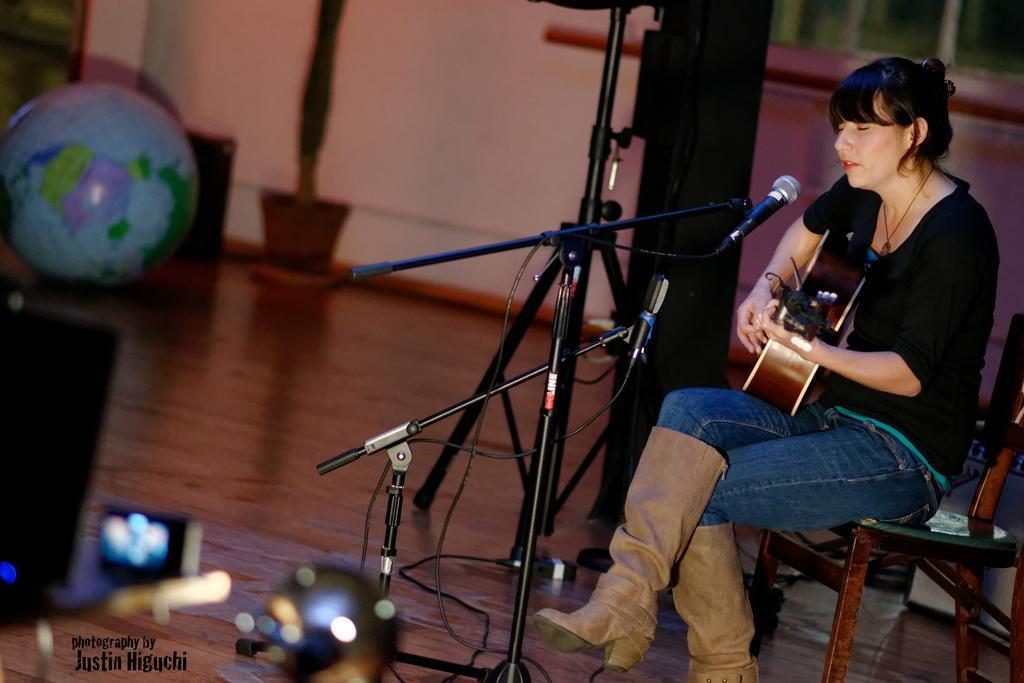Could you give a brief overview of what you see in this image? In this image I see a woman who is sitting on a chair and I see that she is holding a guitar in her hands and I see a tripod in front of her on which there is a mic and I see the globe over here and I see 2 more tripods over here and I see the wires and I see the floor. In the background I see the wall and I see the watermark over here. 